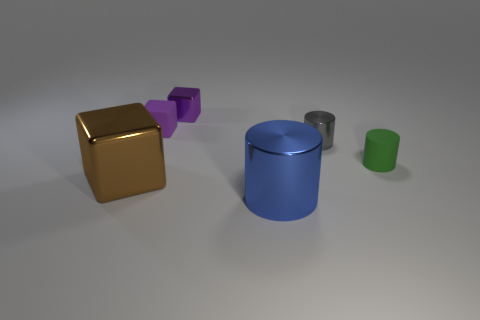Add 3 rubber objects. How many objects exist? 9 Subtract 0 red cylinders. How many objects are left? 6 Subtract all small metallic cylinders. Subtract all gray metal things. How many objects are left? 4 Add 3 large blue metal cylinders. How many large blue metal cylinders are left? 4 Add 5 large metallic blocks. How many large metallic blocks exist? 6 